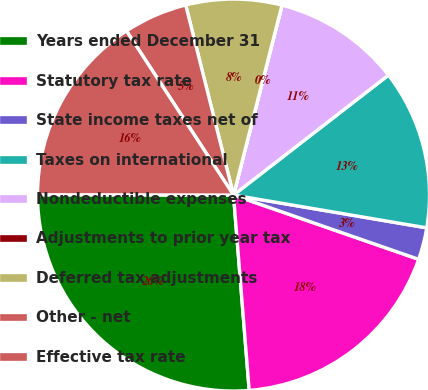<chart> <loc_0><loc_0><loc_500><loc_500><pie_chart><fcel>Years ended December 31<fcel>Statutory tax rate<fcel>State income taxes net of<fcel>Taxes on international<fcel>Nondeductible expenses<fcel>Adjustments to prior year tax<fcel>Deferred tax adjustments<fcel>Other - net<fcel>Effective tax rate<nl><fcel>26.3%<fcel>18.41%<fcel>2.64%<fcel>13.16%<fcel>10.53%<fcel>0.01%<fcel>7.9%<fcel>5.27%<fcel>15.78%<nl></chart> 